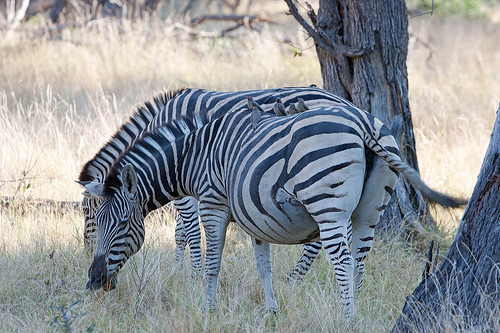Can you tell me more about these zebras' habitat? Certainly! The zebras are in an environment that looks like an African savannah, characterized by scattered trees, grasslands, and a warm climate. This ecosystem supports a diverse array of wildlife and is a natural home for zebras, who require open areas with plenty of grass to feed on and space to be on the lookout for predators. 